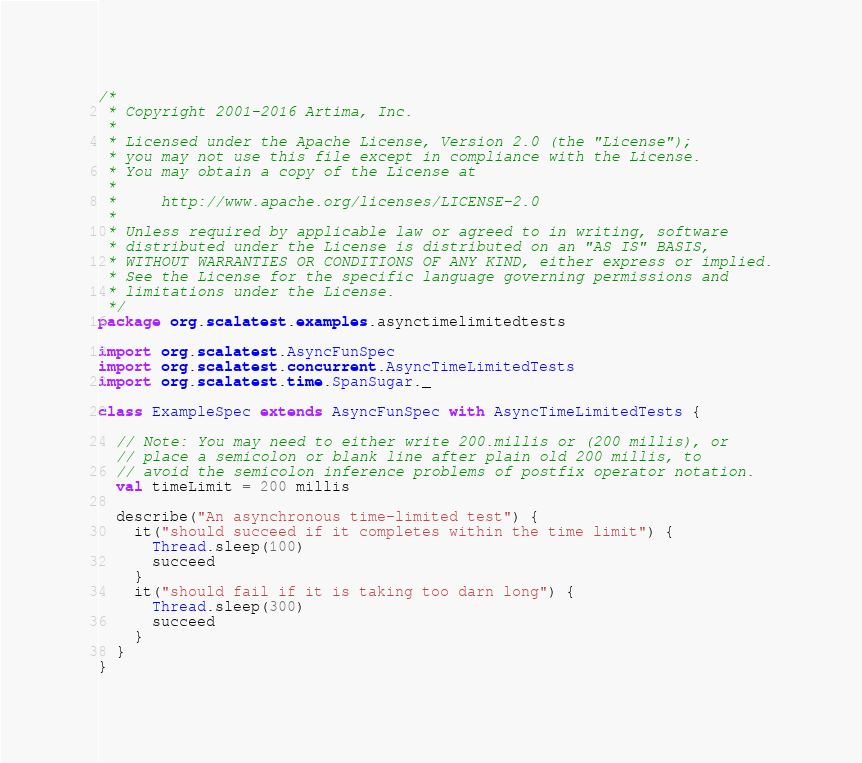<code> <loc_0><loc_0><loc_500><loc_500><_Scala_>/*
 * Copyright 2001-2016 Artima, Inc.
 *
 * Licensed under the Apache License, Version 2.0 (the "License");
 * you may not use this file except in compliance with the License.
 * You may obtain a copy of the License at
 *
 *     http://www.apache.org/licenses/LICENSE-2.0
 *
 * Unless required by applicable law or agreed to in writing, software
 * distributed under the License is distributed on an "AS IS" BASIS,
 * WITHOUT WARRANTIES OR CONDITIONS OF ANY KIND, either express or implied.
 * See the License for the specific language governing permissions and
 * limitations under the License.
 */
package org.scalatest.examples.asynctimelimitedtests

import org.scalatest.AsyncFunSpec
import org.scalatest.concurrent.AsyncTimeLimitedTests
import org.scalatest.time.SpanSugar._

class ExampleSpec extends AsyncFunSpec with AsyncTimeLimitedTests {

  // Note: You may need to either write 200.millis or (200 millis), or
  // place a semicolon or blank line after plain old 200 millis, to
  // avoid the semicolon inference problems of postfix operator notation.
  val timeLimit = 200 millis

  describe("An asynchronous time-limited test") {
    it("should succeed if it completes within the time limit") {
      Thread.sleep(100)
      succeed
    }
    it("should fail if it is taking too darn long") {
      Thread.sleep(300)
      succeed
    }
  }
}</code> 